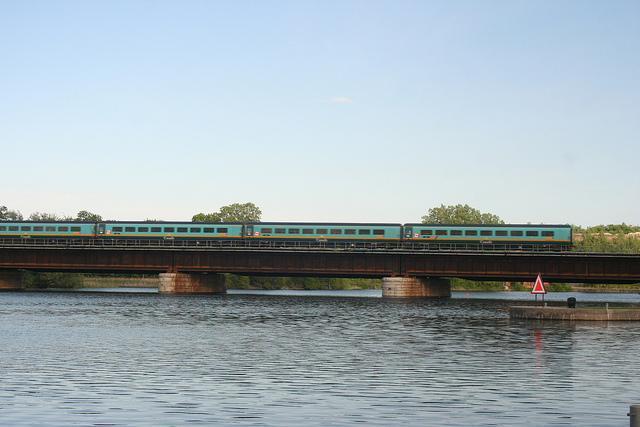How many cars long is the train?
Give a very brief answer. 4. 